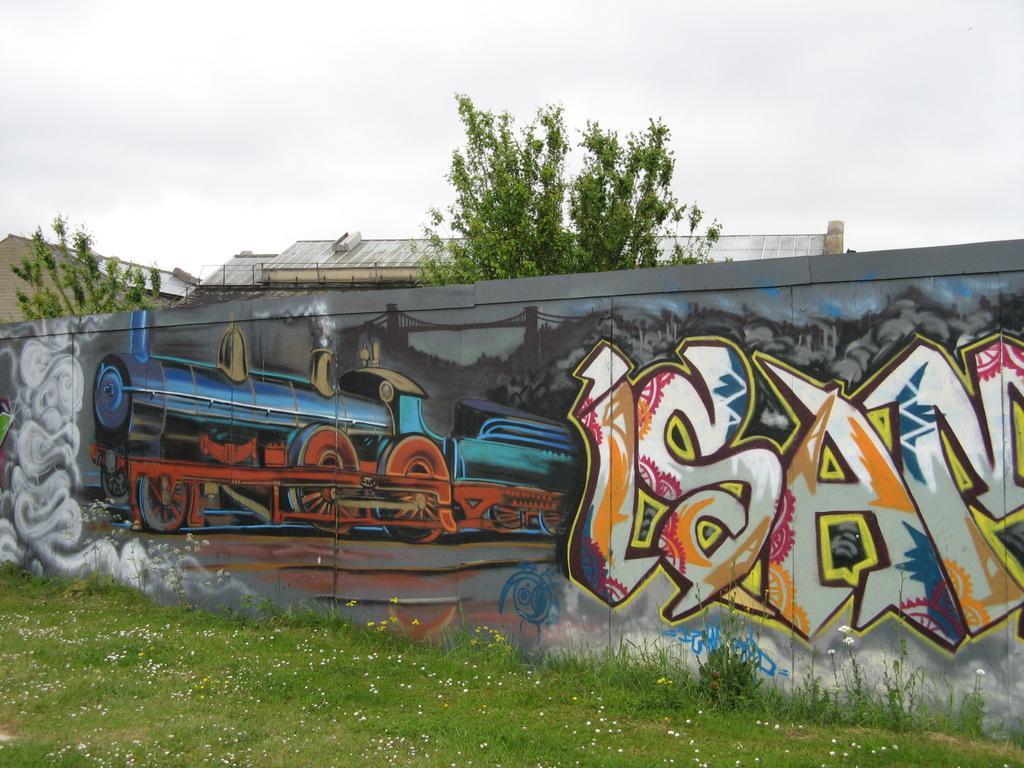Describe this image in one or two sentences. This picture is clicked outside. In the foreground we can see the green grass and plants and we can see a wall on which we can see the picture of a train and we can see the text and the pictures of bridge and some other items. In the background we can see the sky, trees and some buildings. 